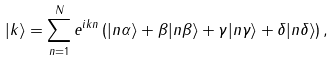Convert formula to latex. <formula><loc_0><loc_0><loc_500><loc_500>| k \rangle = \sum _ { n = 1 } ^ { N } e ^ { i k n } \left ( | n \alpha \rangle + \beta | n \beta \rangle + \gamma | n \gamma \rangle + \delta | n \delta \rangle \right ) ,</formula> 